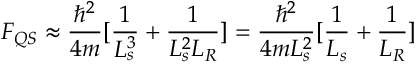Convert formula to latex. <formula><loc_0><loc_0><loc_500><loc_500>F _ { Q S } \approx \frac { \hbar { ^ } { 2 } } { 4 m } [ \frac { 1 } { L _ { s } ^ { 3 } } + \frac { 1 } { L _ { s } ^ { 2 } L _ { R } } ] = \frac { \hbar { ^ } { 2 } } { 4 m L _ { s } ^ { 2 } } [ \frac { 1 } { L _ { s } } + \frac { 1 } { L _ { R } } ]</formula> 